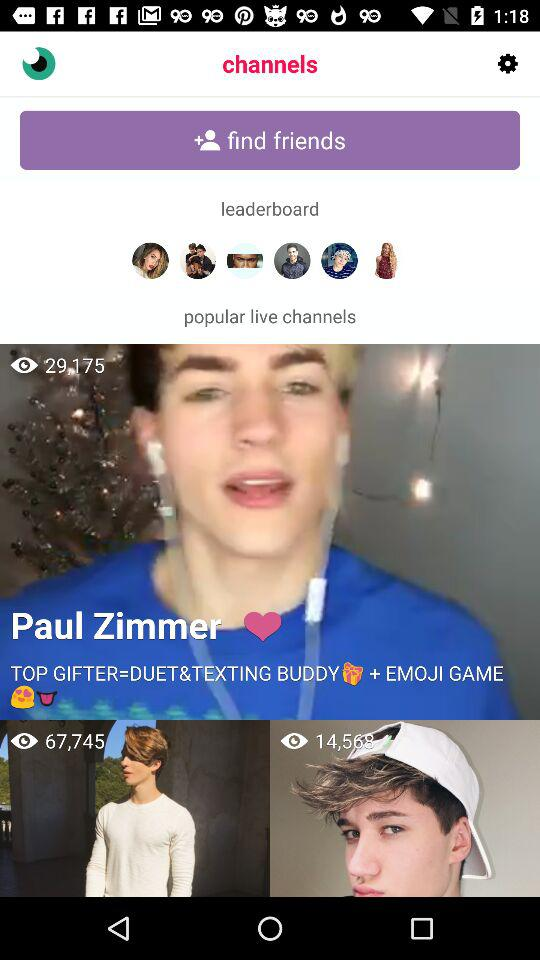Who is the user with 67,745 viewers?
When the provided information is insufficient, respond with <no answer>. <no answer> 